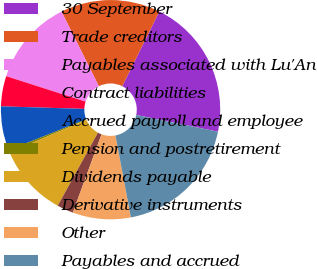Convert chart. <chart><loc_0><loc_0><loc_500><loc_500><pie_chart><fcel>30 September<fcel>Trade creditors<fcel>Payables associated with Lu'An<fcel>Contract liabilities<fcel>Accrued payroll and employee<fcel>Pension and postretirement<fcel>Dividends payable<fcel>Derivative instruments<fcel>Other<fcel>Payables and accrued<nl><fcel>20.88%<fcel>14.72%<fcel>12.67%<fcel>4.46%<fcel>6.51%<fcel>0.35%<fcel>10.62%<fcel>2.41%<fcel>8.56%<fcel>18.81%<nl></chart> 